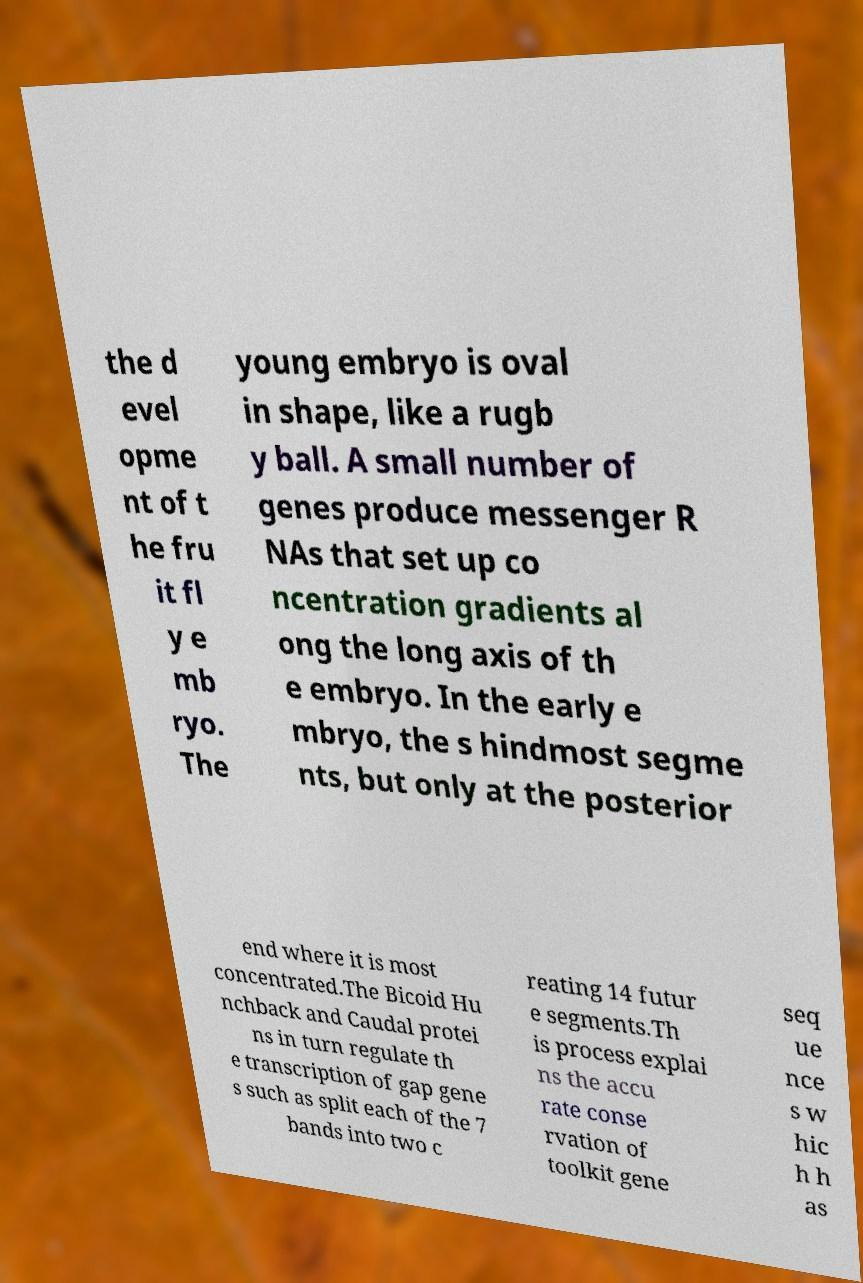There's text embedded in this image that I need extracted. Can you transcribe it verbatim? the d evel opme nt of t he fru it fl y e mb ryo. The young embryo is oval in shape, like a rugb y ball. A small number of genes produce messenger R NAs that set up co ncentration gradients al ong the long axis of th e embryo. In the early e mbryo, the s hindmost segme nts, but only at the posterior end where it is most concentrated.The Bicoid Hu nchback and Caudal protei ns in turn regulate th e transcription of gap gene s such as split each of the 7 bands into two c reating 14 futur e segments.Th is process explai ns the accu rate conse rvation of toolkit gene seq ue nce s w hic h h as 